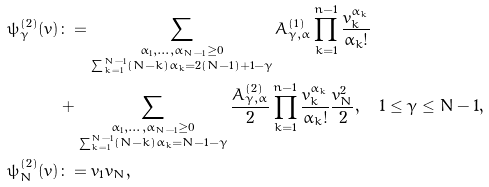Convert formula to latex. <formula><loc_0><loc_0><loc_500><loc_500>\psi _ { \gamma } ^ { ( 2 ) } ( v ) & \colon = \sum _ { \substack { \alpha _ { 1 } , \dots , \alpha _ { N - 1 } \geq 0 \\ \sum _ { k = 1 } ^ { N - 1 } ( N - k ) \alpha _ { k } = 2 ( N - 1 ) + 1 - \gamma } } A ^ { ( 1 ) } _ { \gamma , \alpha } \prod _ { k = 1 } ^ { n - 1 } \frac { v _ { k } ^ { \alpha _ { k } } } { \alpha _ { k } ! } \\ & + \sum _ { \substack { \alpha _ { 1 } , \dots , \alpha _ { N - 1 } \geq 0 \\ \sum _ { k = 1 } ^ { N - 1 } ( N - k ) \alpha _ { k } = N - 1 - \gamma } } \frac { A ^ { ( 2 ) } _ { \gamma , \alpha } } { 2 } \prod _ { k = 1 } ^ { n - 1 } \frac { v _ { k } ^ { \alpha _ { k } } } { \alpha _ { k } ! } \frac { v _ { N } ^ { 2 } } { 2 } , \quad 1 \leq \gamma \leq N - 1 , \\ \psi _ { N } ^ { ( 2 ) } ( v ) & \colon = v _ { 1 } v _ { N } ,</formula> 